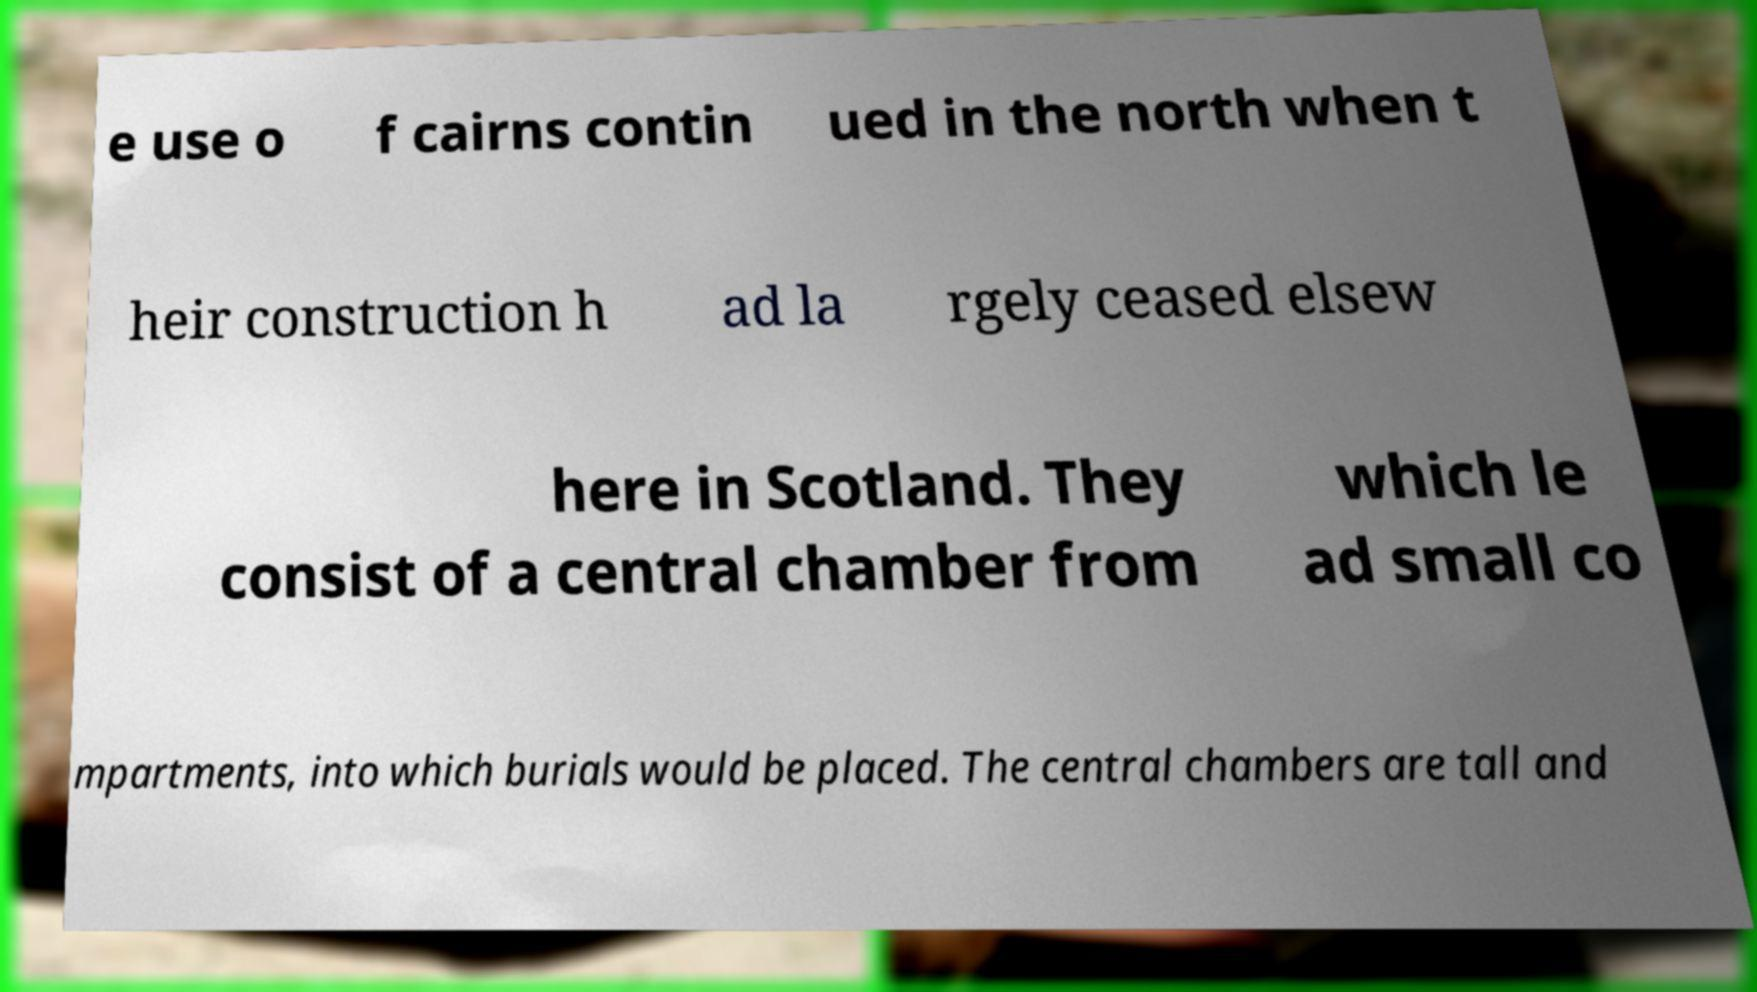Could you extract and type out the text from this image? e use o f cairns contin ued in the north when t heir construction h ad la rgely ceased elsew here in Scotland. They consist of a central chamber from which le ad small co mpartments, into which burials would be placed. The central chambers are tall and 